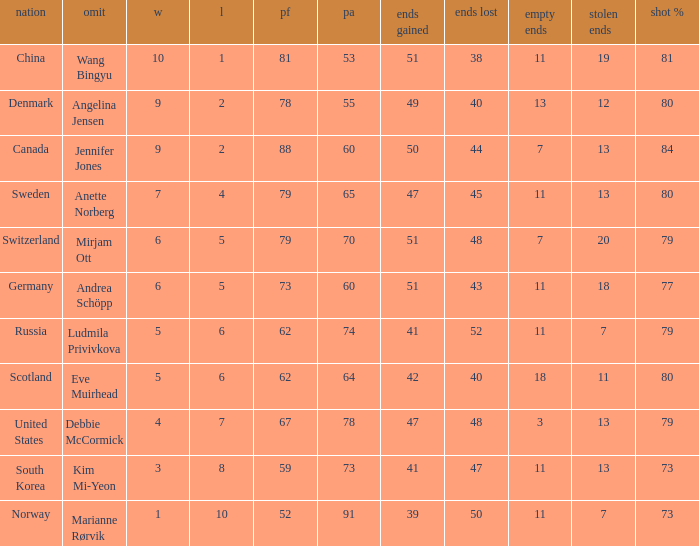When the country was Scotland, how many ends were won? 1.0. 